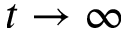Convert formula to latex. <formula><loc_0><loc_0><loc_500><loc_500>t \to \infty</formula> 